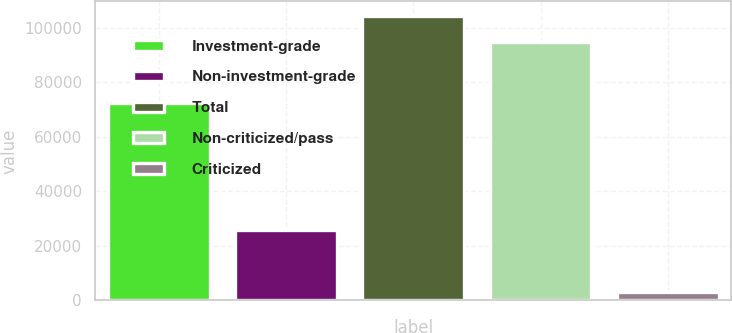Convert chart to OTSL. <chart><loc_0><loc_0><loc_500><loc_500><bar_chart><fcel>Investment-grade<fcel>Non-investment-grade<fcel>Total<fcel>Non-criticized/pass<fcel>Criticized<nl><fcel>72323<fcel>25722<fcel>104463<fcel>94966<fcel>3079<nl></chart> 